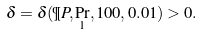<formula> <loc_0><loc_0><loc_500><loc_500>\delta = \delta ( \P P , \Pr _ { 1 } , 1 0 0 , 0 . 0 1 ) > 0 .</formula> 